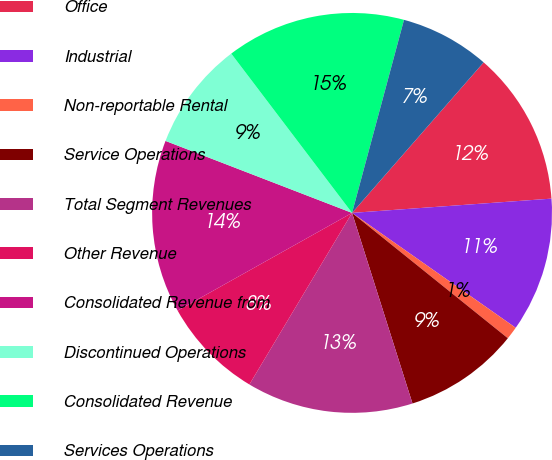Convert chart. <chart><loc_0><loc_0><loc_500><loc_500><pie_chart><fcel>Office<fcel>Industrial<fcel>Non-reportable Rental<fcel>Service Operations<fcel>Total Segment Revenues<fcel>Other Revenue<fcel>Consolidated Revenue from<fcel>Discontinued Operations<fcel>Consolidated Revenue<fcel>Services Operations<nl><fcel>12.43%<fcel>10.88%<fcel>1.04%<fcel>9.33%<fcel>13.47%<fcel>8.29%<fcel>13.99%<fcel>8.81%<fcel>14.51%<fcel>7.25%<nl></chart> 